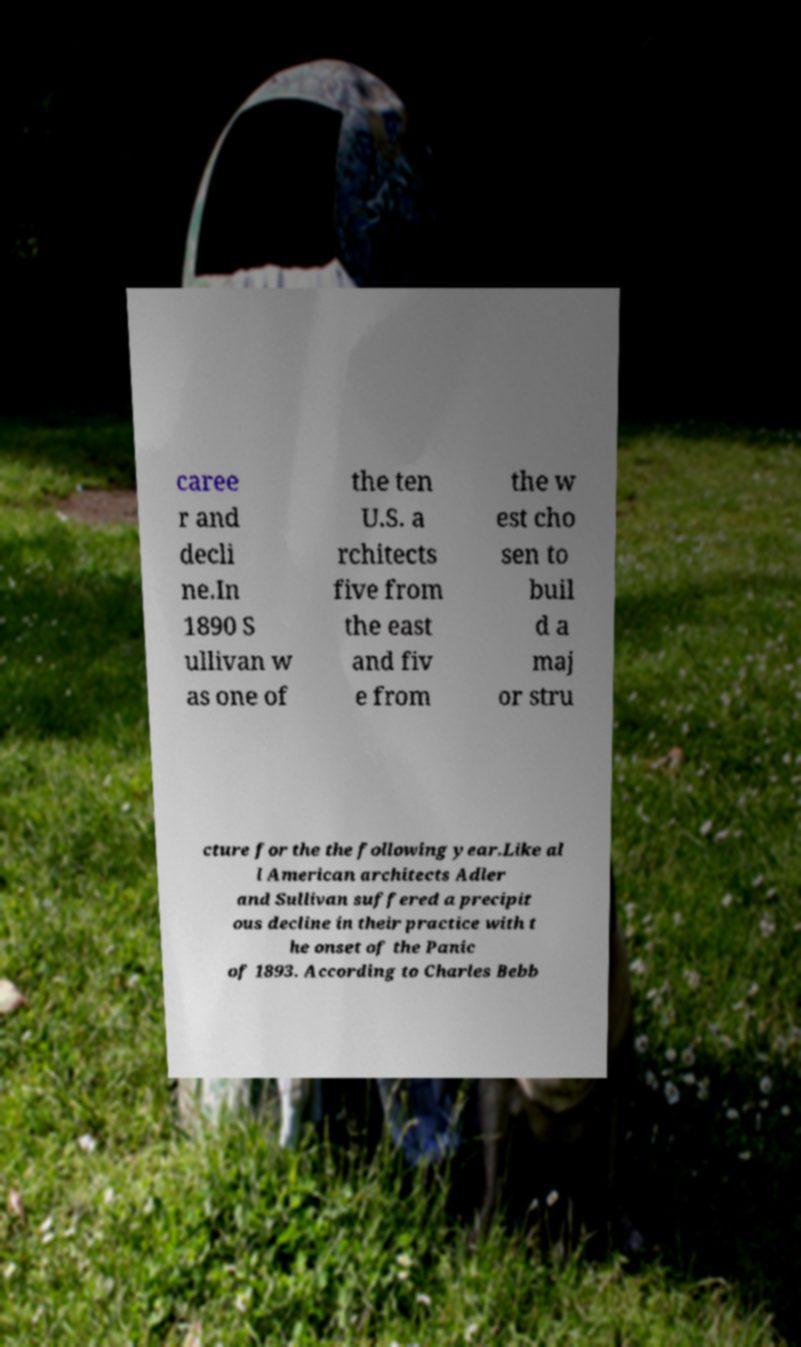Please read and relay the text visible in this image. What does it say? caree r and decli ne.In 1890 S ullivan w as one of the ten U.S. a rchitects five from the east and fiv e from the w est cho sen to buil d a maj or stru cture for the the following year.Like al l American architects Adler and Sullivan suffered a precipit ous decline in their practice with t he onset of the Panic of 1893. According to Charles Bebb 